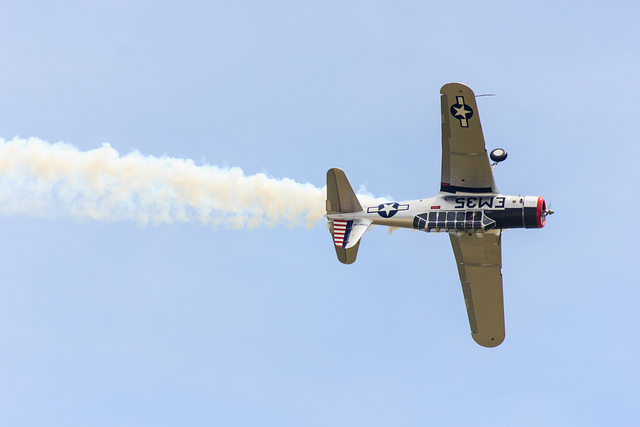Please extract the text content from this image. EM35 